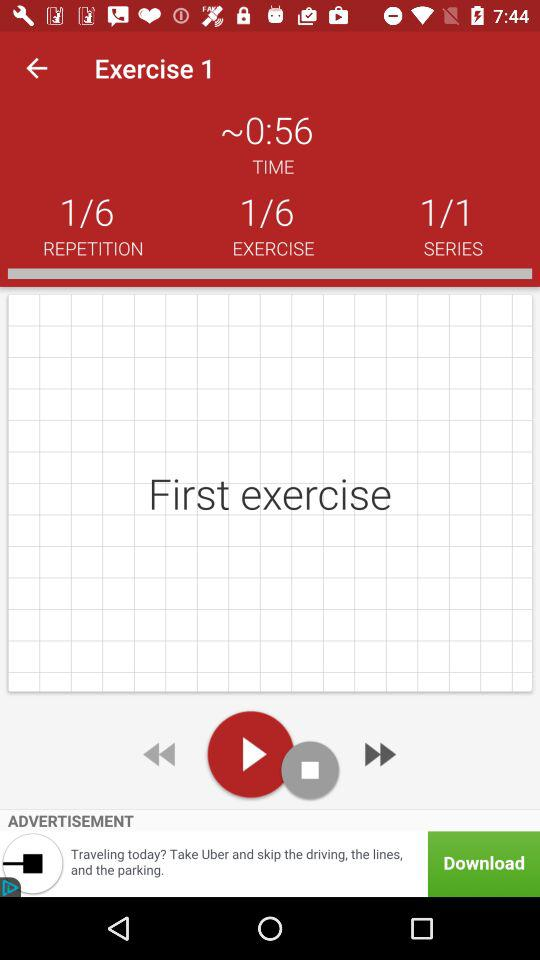What is the total time spent on the exercise? The total time spent on the exercise is approximately 56 seconds. 